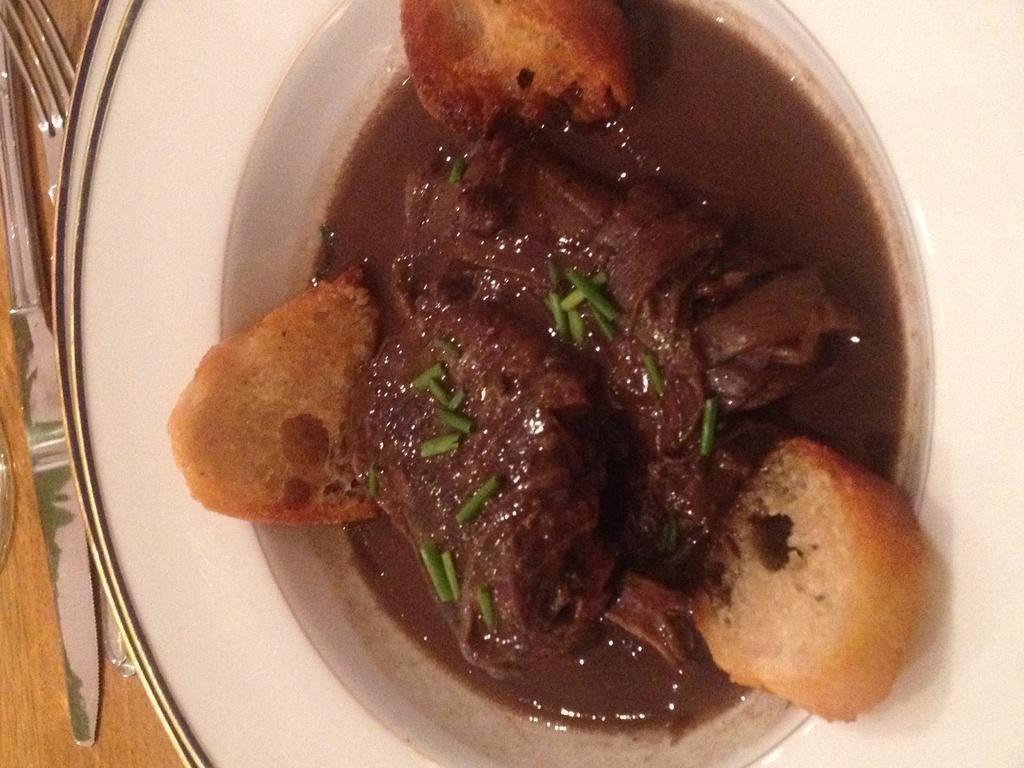Describe this image in one or two sentences. In the image there is some cooked food item served in a plate, beside that there is a fork. 